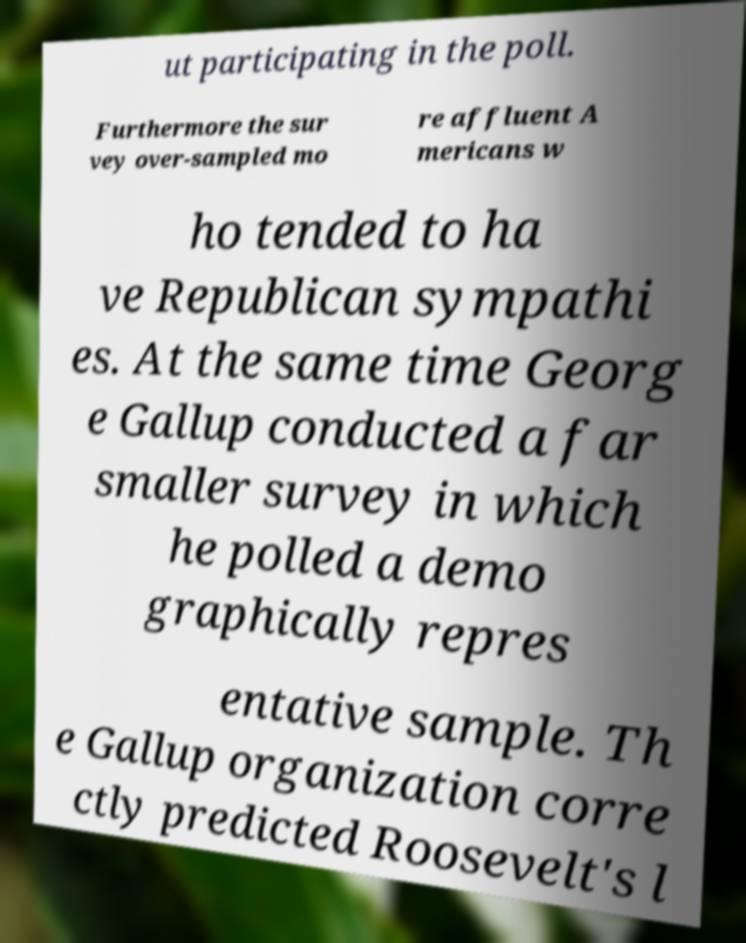Can you read and provide the text displayed in the image?This photo seems to have some interesting text. Can you extract and type it out for me? ut participating in the poll. Furthermore the sur vey over-sampled mo re affluent A mericans w ho tended to ha ve Republican sympathi es. At the same time Georg e Gallup conducted a far smaller survey in which he polled a demo graphically repres entative sample. Th e Gallup organization corre ctly predicted Roosevelt's l 